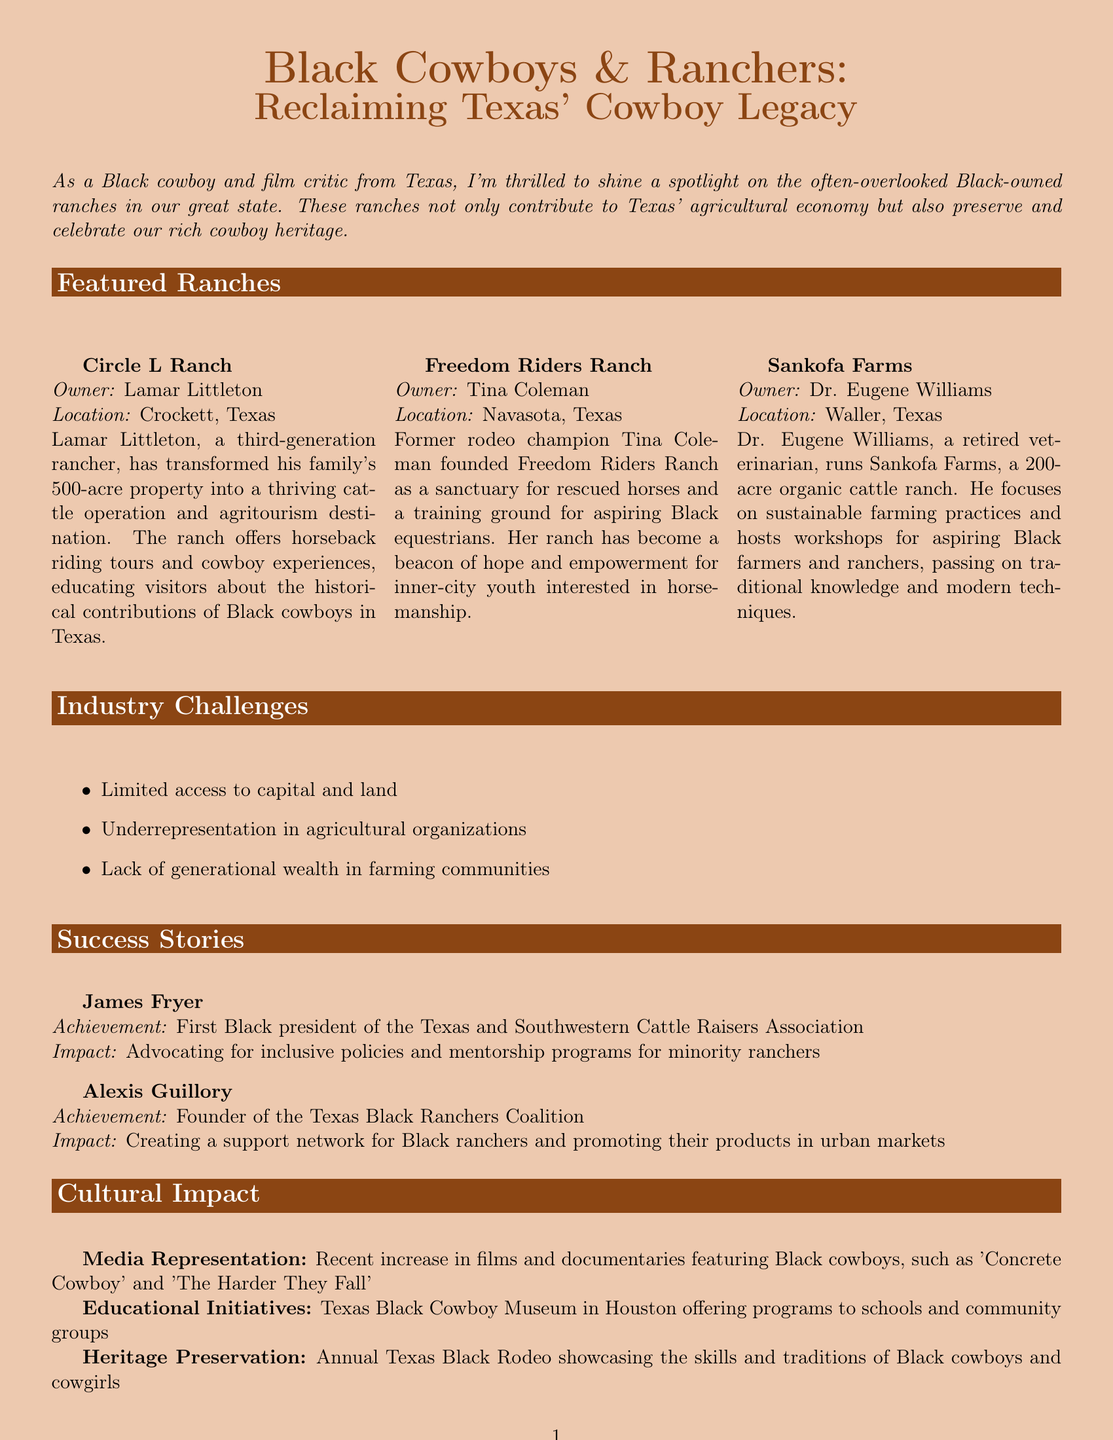What is the title of the newsletter? The title is stated at the beginning of the document as "Black Cowboys & Ranchers: Reclaiming Texas' Cowboy Legacy."
Answer: Black Cowboys & Ranchers: Reclaiming Texas' Cowboy Legacy Who owns Circle L Ranch? The owner's name is listed in the featured ranches section as Lamar Littleton.
Answer: Lamar Littleton What type of animal does Sankofa Farms focus on? The document mentions that Dr. Eugene Williams runs an organic cattle ranch, indicating that cattle is the focus.
Answer: Cattle What significant role does James Fryer hold? His achievement as the first Black president of the Texas and Southwestern Cattle Raisers Association is highlighted in the success stories section.
Answer: First Black president How many acres does Sankofa Farms cover? The document states that Sankofa Farms is a 200-acre ranch, providing the specific size in the description.
Answer: 200 acres What issues do Black ranchers face according to the document? The newsletter lists several challenges, including limited access to capital and land, indicating the systemic issues that exist.
Answer: Limited access to capital and land Which ranch focuses on empowering inner-city youth? Freedom Riders Ranch is highlighted in the document for its role in supporting aspiring Black equestrians from inner-city backgrounds.
Answer: Freedom Riders Ranch What cultural event showcases skills and traditions of Black cowboys? The document mentions the Annual Texas Black Rodeo, which focuses on heritage preservation among Black cowboys.
Answer: Annual Texas Black Rodeo 